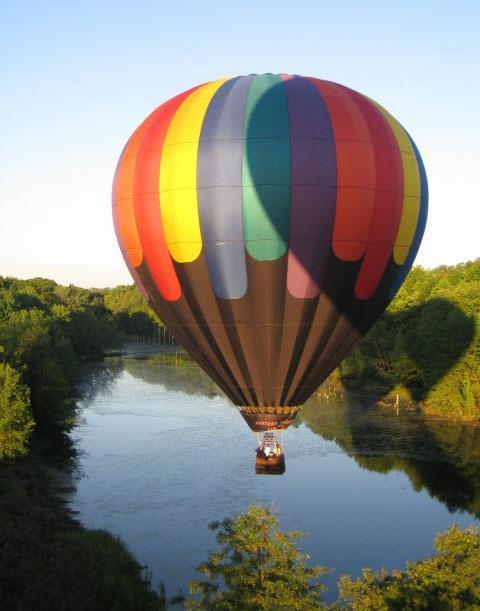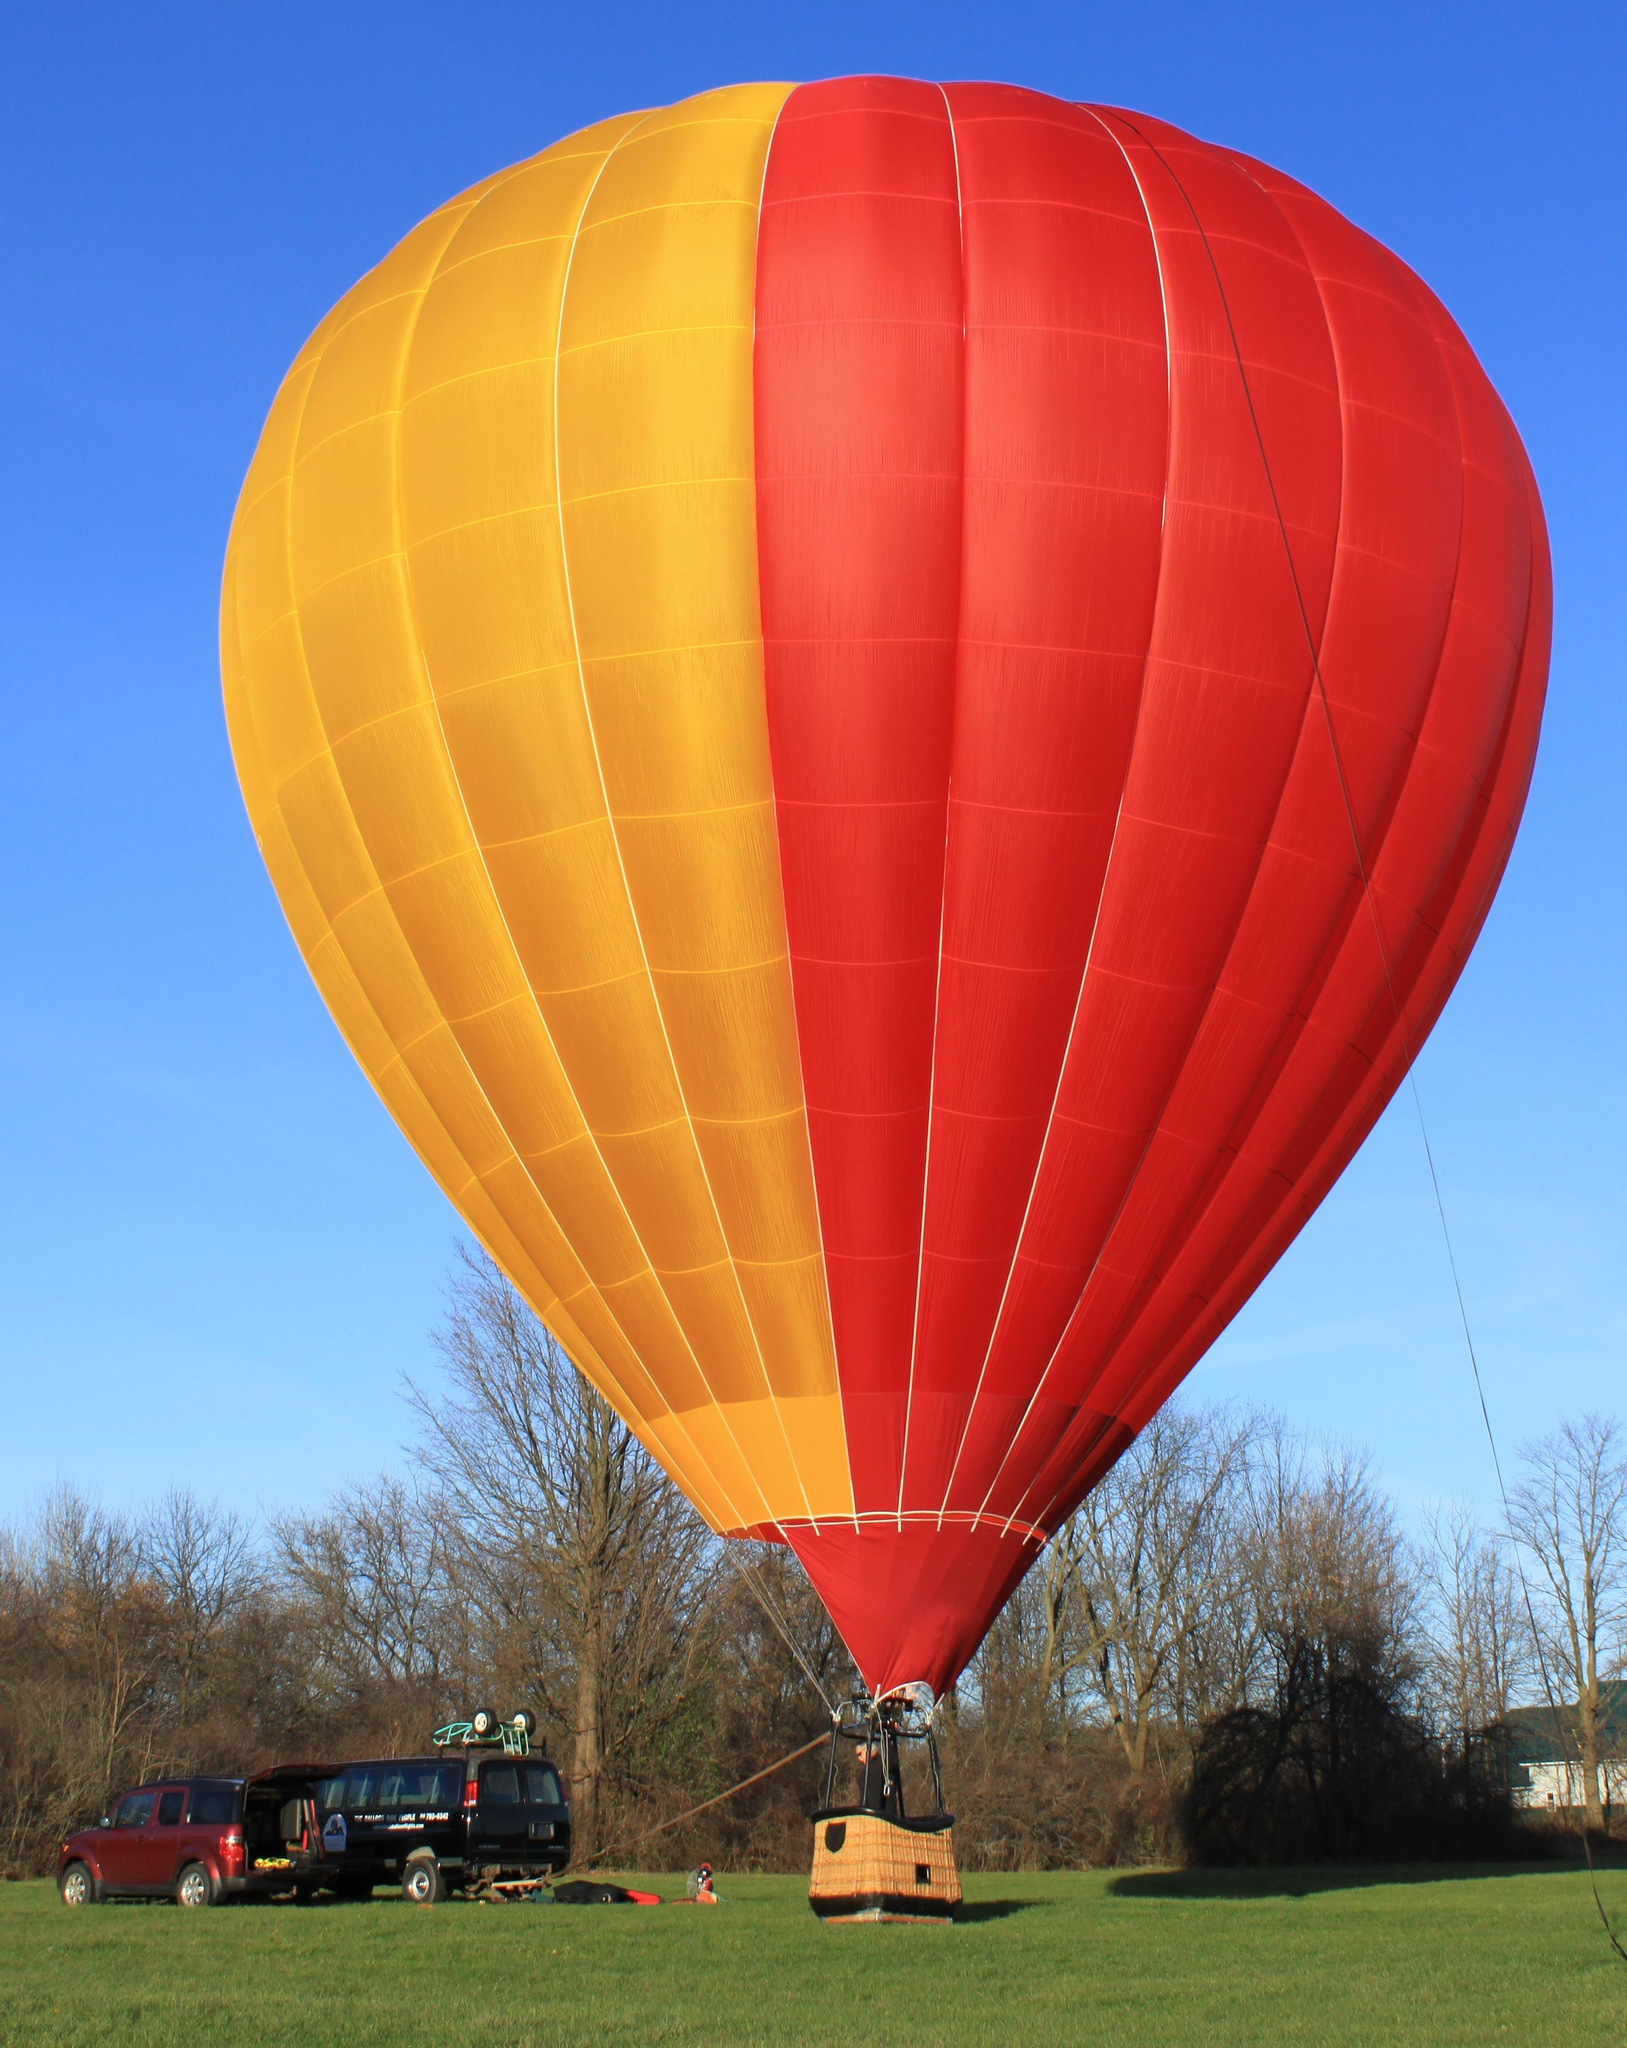The first image is the image on the left, the second image is the image on the right. Analyze the images presented: Is the assertion "One of the balloons has a face depicted on it." valid? Answer yes or no. No. 